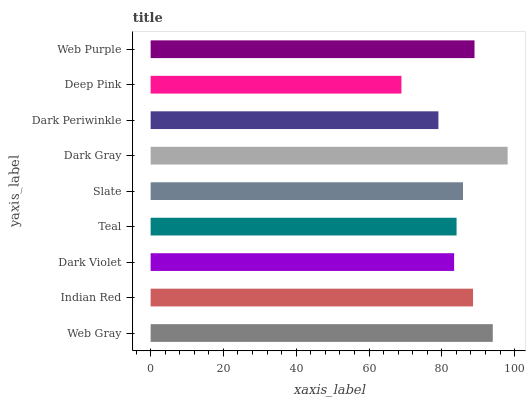Is Deep Pink the minimum?
Answer yes or no. Yes. Is Dark Gray the maximum?
Answer yes or no. Yes. Is Indian Red the minimum?
Answer yes or no. No. Is Indian Red the maximum?
Answer yes or no. No. Is Web Gray greater than Indian Red?
Answer yes or no. Yes. Is Indian Red less than Web Gray?
Answer yes or no. Yes. Is Indian Red greater than Web Gray?
Answer yes or no. No. Is Web Gray less than Indian Red?
Answer yes or no. No. Is Slate the high median?
Answer yes or no. Yes. Is Slate the low median?
Answer yes or no. Yes. Is Indian Red the high median?
Answer yes or no. No. Is Web Purple the low median?
Answer yes or no. No. 